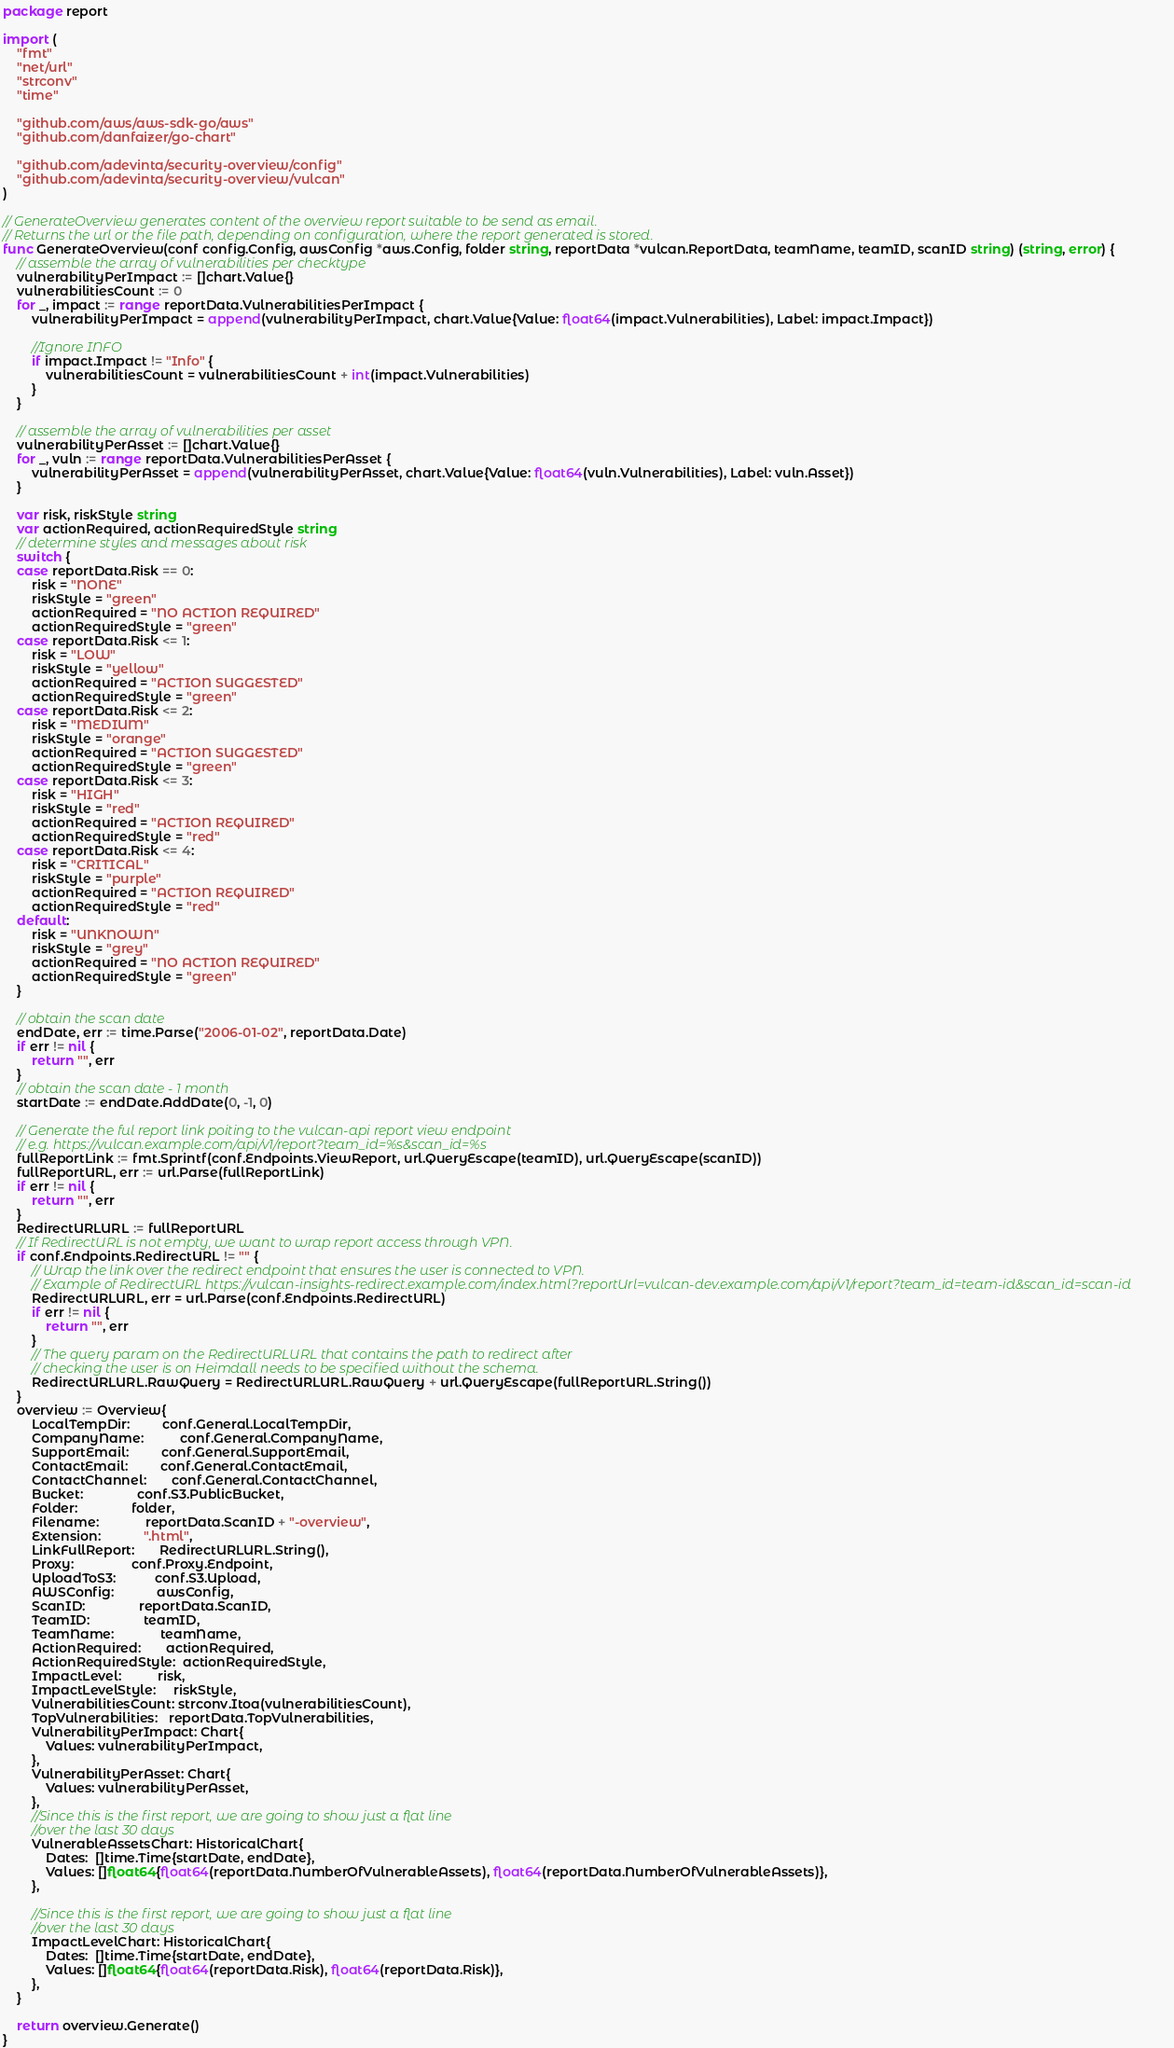Convert code to text. <code><loc_0><loc_0><loc_500><loc_500><_Go_>package report

import (
	"fmt"
	"net/url"
	"strconv"
	"time"

	"github.com/aws/aws-sdk-go/aws"
	"github.com/danfaizer/go-chart"

	"github.com/adevinta/security-overview/config"
	"github.com/adevinta/security-overview/vulcan"
)

// GenerateOverview generates content of the overview report suitable to be send as email.
// Returns the url or the file path, depending on configuration, where the report generated is stored.
func GenerateOverview(conf config.Config, awsConfig *aws.Config, folder string, reportData *vulcan.ReportData, teamName, teamID, scanID string) (string, error) {
	// assemble the array of vulnerabilities per checktype
	vulnerabilityPerImpact := []chart.Value{}
	vulnerabilitiesCount := 0
	for _, impact := range reportData.VulnerabilitiesPerImpact {
		vulnerabilityPerImpact = append(vulnerabilityPerImpact, chart.Value{Value: float64(impact.Vulnerabilities), Label: impact.Impact})

		//Ignore INFO
		if impact.Impact != "Info" {
			vulnerabilitiesCount = vulnerabilitiesCount + int(impact.Vulnerabilities)
		}
	}

	// assemble the array of vulnerabilities per asset
	vulnerabilityPerAsset := []chart.Value{}
	for _, vuln := range reportData.VulnerabilitiesPerAsset {
		vulnerabilityPerAsset = append(vulnerabilityPerAsset, chart.Value{Value: float64(vuln.Vulnerabilities), Label: vuln.Asset})
	}

	var risk, riskStyle string
	var actionRequired, actionRequiredStyle string
	// determine styles and messages about risk
	switch {
	case reportData.Risk == 0:
		risk = "NONE"
		riskStyle = "green"
		actionRequired = "NO ACTION REQUIRED"
		actionRequiredStyle = "green"
	case reportData.Risk <= 1:
		risk = "LOW"
		riskStyle = "yellow"
		actionRequired = "ACTION SUGGESTED"
		actionRequiredStyle = "green"
	case reportData.Risk <= 2:
		risk = "MEDIUM"
		riskStyle = "orange"
		actionRequired = "ACTION SUGGESTED"
		actionRequiredStyle = "green"
	case reportData.Risk <= 3:
		risk = "HIGH"
		riskStyle = "red"
		actionRequired = "ACTION REQUIRED"
		actionRequiredStyle = "red"
	case reportData.Risk <= 4:
		risk = "CRITICAL"
		riskStyle = "purple"
		actionRequired = "ACTION REQUIRED"
		actionRequiredStyle = "red"
	default:
		risk = "UNKNOWN"
		riskStyle = "grey"
		actionRequired = "NO ACTION REQUIRED"
		actionRequiredStyle = "green"
	}

	// obtain the scan date
	endDate, err := time.Parse("2006-01-02", reportData.Date)
	if err != nil {
		return "", err
	}
	// obtain the scan date - 1 month
	startDate := endDate.AddDate(0, -1, 0)

	// Generate the ful report link poiting to the vulcan-api report view endpoint
	// e.g. https://vulcan.example.com/api/v1/report?team_id=%s&scan_id=%s
	fullReportLink := fmt.Sprintf(conf.Endpoints.ViewReport, url.QueryEscape(teamID), url.QueryEscape(scanID))
	fullReportURL, err := url.Parse(fullReportLink)
	if err != nil {
		return "", err
	}
	RedirectURLURL := fullReportURL
	// If RedirectURL is not empty, we want to wrap report access through VPN.
	if conf.Endpoints.RedirectURL != "" {
		// Wrap the link over the redirect endpoint that ensures the user is connected to VPN.
		// Example of RedirectURL https://vulcan-insights-redirect.example.com/index.html?reportUrl=vulcan-dev.example.com/api/v1/report?team_id=team-id&scan_id=scan-id
		RedirectURLURL, err = url.Parse(conf.Endpoints.RedirectURL)
		if err != nil {
			return "", err
		}
		// The query param on the RedirectURLURL that contains the path to redirect after
		// checking the user is on Heimdall needs to be specified without the schema.
		RedirectURLURL.RawQuery = RedirectURLURL.RawQuery + url.QueryEscape(fullReportURL.String())
	}
	overview := Overview{
		LocalTempDir:         conf.General.LocalTempDir,
		CompanyName:          conf.General.CompanyName,
		SupportEmail:         conf.General.SupportEmail,
		ContactEmail:         conf.General.ContactEmail,
		ContactChannel:       conf.General.ContactChannel,
		Bucket:               conf.S3.PublicBucket,
		Folder:               folder,
		Filename:             reportData.ScanID + "-overview",
		Extension:            ".html",
		LinkFullReport:       RedirectURLURL.String(),
		Proxy:                conf.Proxy.Endpoint,
		UploadToS3:           conf.S3.Upload,
		AWSConfig:            awsConfig,
		ScanID:               reportData.ScanID,
		TeamID:               teamID,
		TeamName:             teamName,
		ActionRequired:       actionRequired,
		ActionRequiredStyle:  actionRequiredStyle,
		ImpactLevel:          risk,
		ImpactLevelStyle:     riskStyle,
		VulnerabilitiesCount: strconv.Itoa(vulnerabilitiesCount),
		TopVulnerabilities:   reportData.TopVulnerabilities,
		VulnerabilityPerImpact: Chart{
			Values: vulnerabilityPerImpact,
		},
		VulnerabilityPerAsset: Chart{
			Values: vulnerabilityPerAsset,
		},
		//Since this is the first report, we are going to show just a flat line
		//over the last 30 days
		VulnerableAssetsChart: HistoricalChart{
			Dates:  []time.Time{startDate, endDate},
			Values: []float64{float64(reportData.NumberOfVulnerableAssets), float64(reportData.NumberOfVulnerableAssets)},
		},

		//Since this is the first report, we are going to show just a flat line
		//over the last 30 days
		ImpactLevelChart: HistoricalChart{
			Dates:  []time.Time{startDate, endDate},
			Values: []float64{float64(reportData.Risk), float64(reportData.Risk)},
		},
	}

	return overview.Generate()
}
</code> 